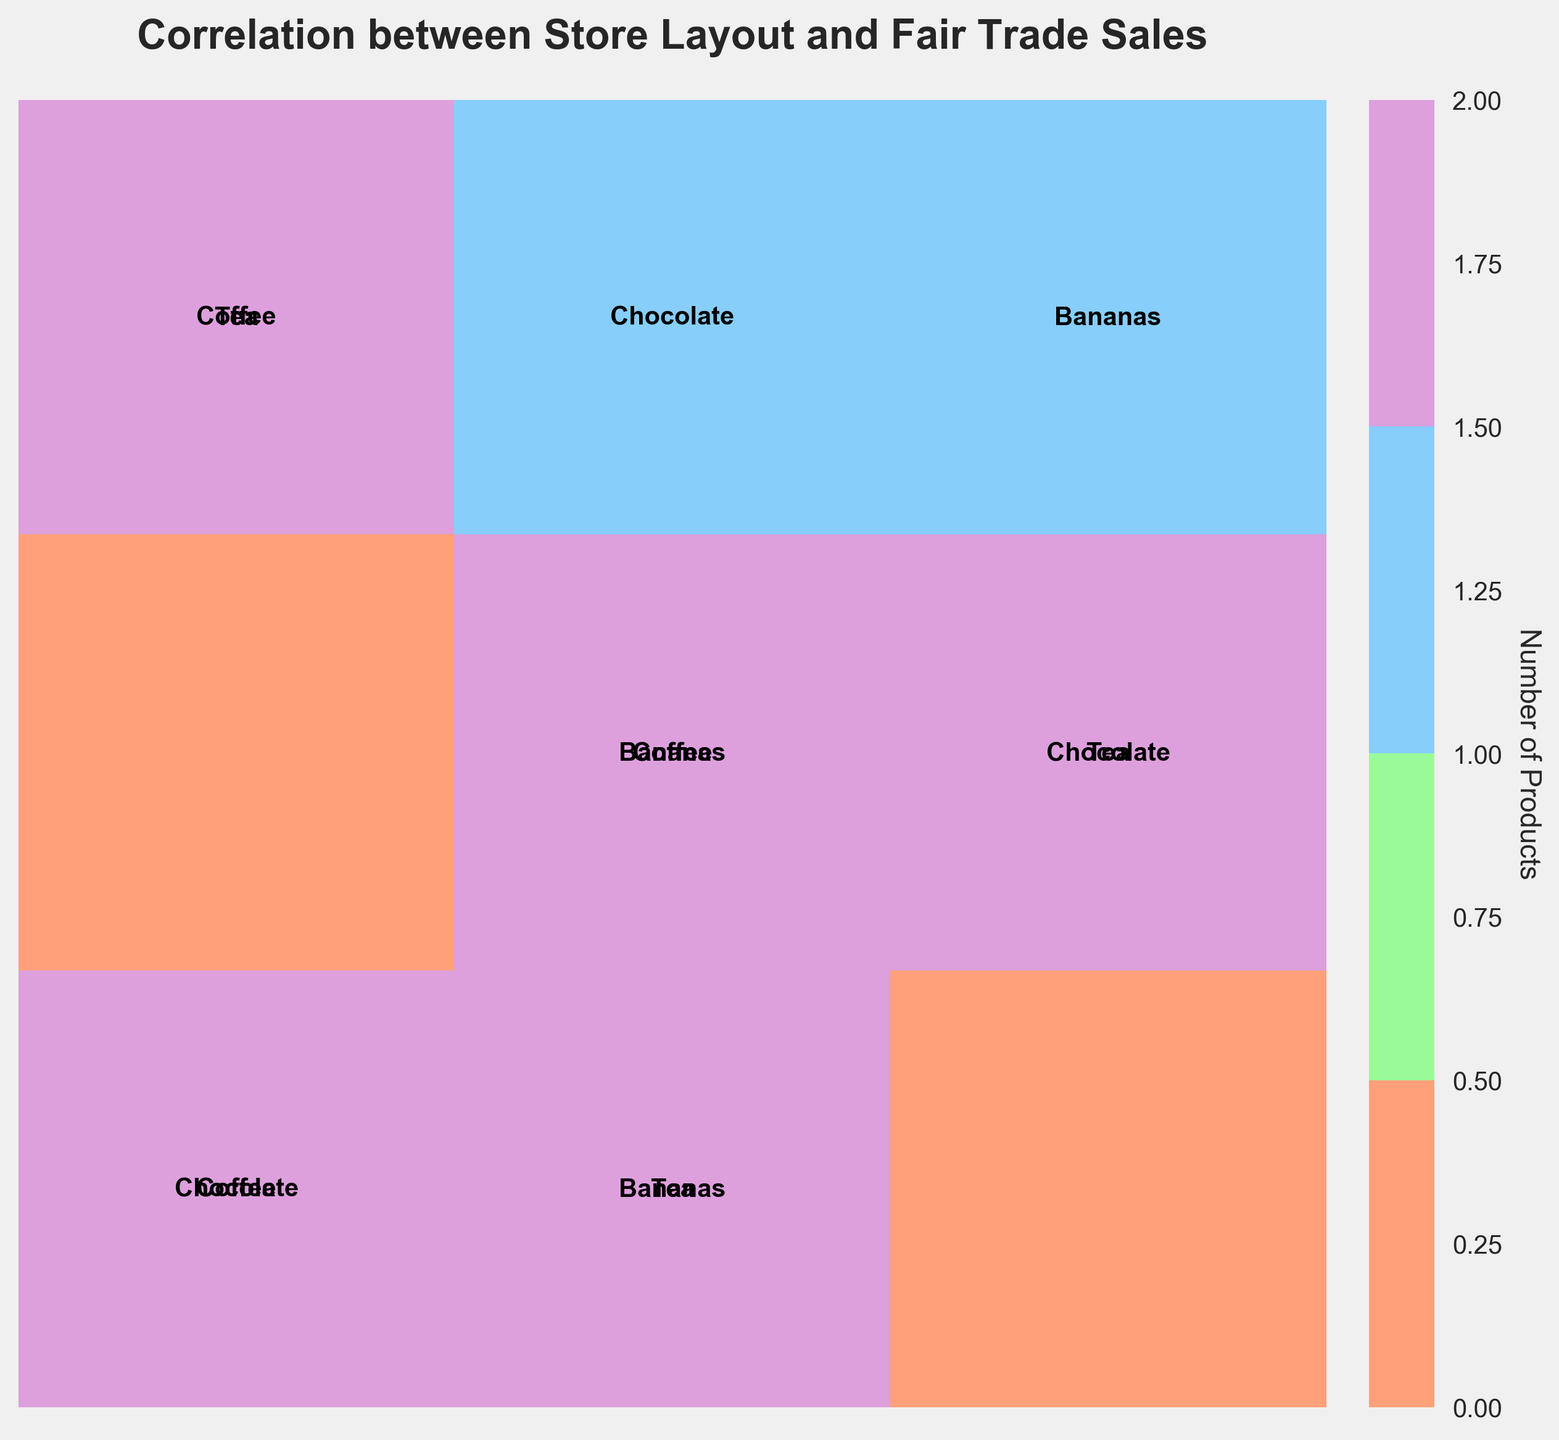Which store layout has the highest number of high fair trade sales? First, observe the 'High' column for fair trade sales. There are three rows, one for each store layout. Check the cells that sum up higher in shades for 'High' fair trade sales.
Answer: Marketplace Style Which product category shows high fair-trade sales for Open Floor Plan and Marketplace Style layouts? Look at cells with high fair-trade sales for both layouts. For Open Floor Plan, high sales are in Coffee and Tea. For Marketplace Style, high sales are in Coffee and Chocolate.
Answer: Coffee What is the most frequent fair trade sales level for the Aisle-based layout? Review the rows for Aisle-based layout. The cells show medium and low sales more frequently, with higher prominence for low sales in all product categories.
Answer: Low How many different fair trade sales levels are there? Review the x-axis to identify the number of unique labels. The axis lists three categories: High, Medium, and Low.
Answer: Three Are there any products with high fair trade sales in the Aisle-based layout? Look at cells corresponding to Aisle-based layout and high fair trade sales. There are no cells indicating high fair trade sales for any product category.
Answer: No Which product category has medium fair trade sales across all layouts? Identify the product categories within the Medium fair trade sales cells for each layout. Bananas are found in medium fair trade sales for all layouts.
Answer: Bananas Which layout has diversity in fair trade sales levels across product categories? Compare cells for varying fair trade sales levels within each layout. Open Floor Plan shows High, Medium, and Low sales across different products, indicating the most diversity.
Answer: Open Floor Plan Which product category contributes equally to high fair trade sales in both Open Floor Plan and Marketplace Style layouts? Evaluate cells of high fair trade sales for both the mentioned layouts. Coffee contributes to high fair trade sales in both layouts.
Answer: Coffee How does the Marketplace Style layout compare to the Aisle-based layout in terms of fair trade sales for Tea? Review the mentioned layouts for Tea. Marketplace Style has medium sales for Tea while Aisle-based layout has low sales.
Answer: Marketplace Style has higher sales What is the predominant product category with high fair trade sales for the Marketplace Style layout? Analyze high fair trade sales cells in the Marketplace Style row. Both Coffee and Chocolate are present. Coffee is the predominant category seen in multiple contexts.
Answer: Coffee 